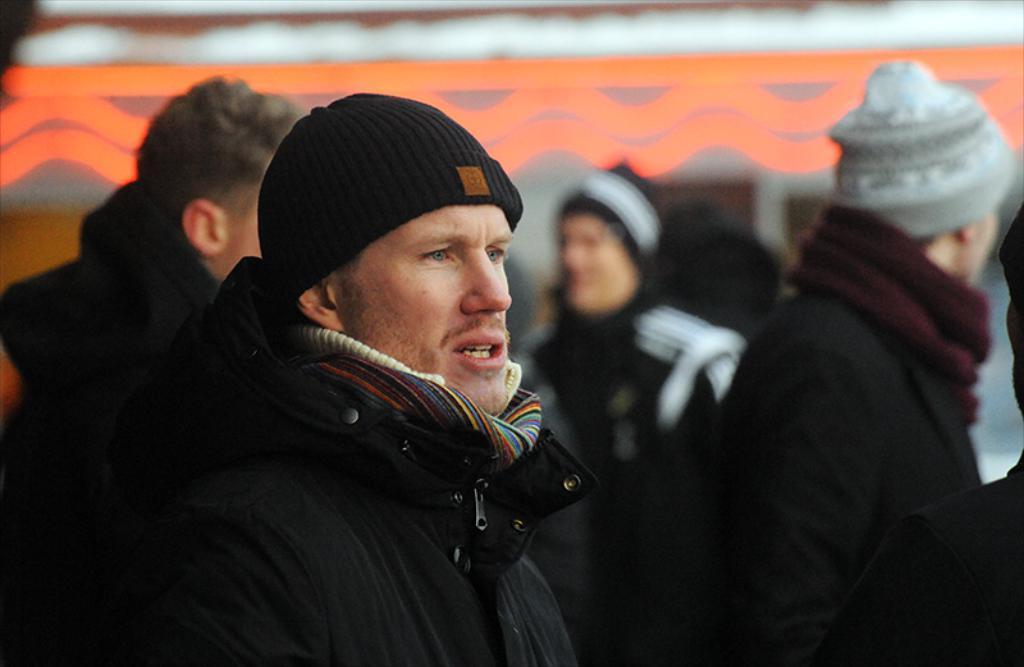Can you describe this image briefly? In this image in the middle there is a man, he wears a jacket, cap. On the right there is a man, he wears a jacket, cap. In the background there are many people and building. 